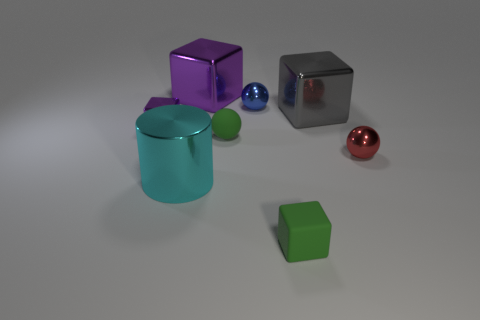Is the small blue metallic thing the same shape as the cyan object?
Offer a terse response. No. What number of matte things are purple cubes or cyan things?
Offer a very short reply. 0. How many green objects are there?
Offer a terse response. 2. What color is the shiny block that is the same size as the matte cube?
Make the answer very short. Purple. Do the green matte ball and the cyan cylinder have the same size?
Offer a very short reply. No. There is a matte thing that is the same color as the tiny matte cube; what is its shape?
Provide a short and direct response. Sphere. There is a metal cylinder; is it the same size as the green object on the right side of the green sphere?
Your answer should be very brief. No. What is the color of the shiny block that is in front of the small blue object and on the left side of the small green rubber ball?
Your answer should be very brief. Purple. Is the number of tiny blue spheres that are in front of the blue metallic ball greater than the number of blue spheres that are to the right of the large cyan thing?
Ensure brevity in your answer.  No. What is the size of the cylinder that is made of the same material as the red ball?
Keep it short and to the point. Large. 